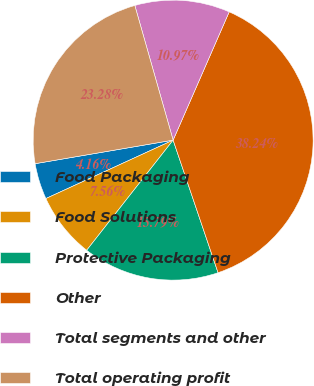<chart> <loc_0><loc_0><loc_500><loc_500><pie_chart><fcel>Food Packaging<fcel>Food Solutions<fcel>Protective Packaging<fcel>Other<fcel>Total segments and other<fcel>Total operating profit<nl><fcel>4.16%<fcel>7.56%<fcel>15.79%<fcel>38.24%<fcel>10.97%<fcel>23.28%<nl></chart> 